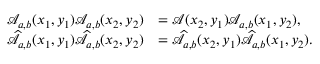<formula> <loc_0><loc_0><loc_500><loc_500>\begin{array} { r l } { \mathcal { A } _ { a , b } ( x _ { 1 } , y _ { 1 } ) \mathcal { A } _ { a , b } ( x _ { 2 } , y _ { 2 } ) } & { = \mathcal { A } ( x _ { 2 } , y _ { 1 } ) \mathcal { A } _ { a , b } ( x _ { 1 } , y _ { 2 } ) , } \\ { \widehat { \mathcal { A } } _ { a , b } ( x _ { 1 } , y _ { 1 } ) \widehat { \mathcal { A } } _ { a , b } ( x _ { 2 } , y _ { 2 } ) } & { = \widehat { \mathcal { A } } _ { a , b } ( x _ { 2 } , y _ { 1 } ) \widehat { \mathcal { A } } _ { a , b } ( x _ { 1 } , y _ { 2 } ) . } \end{array}</formula> 